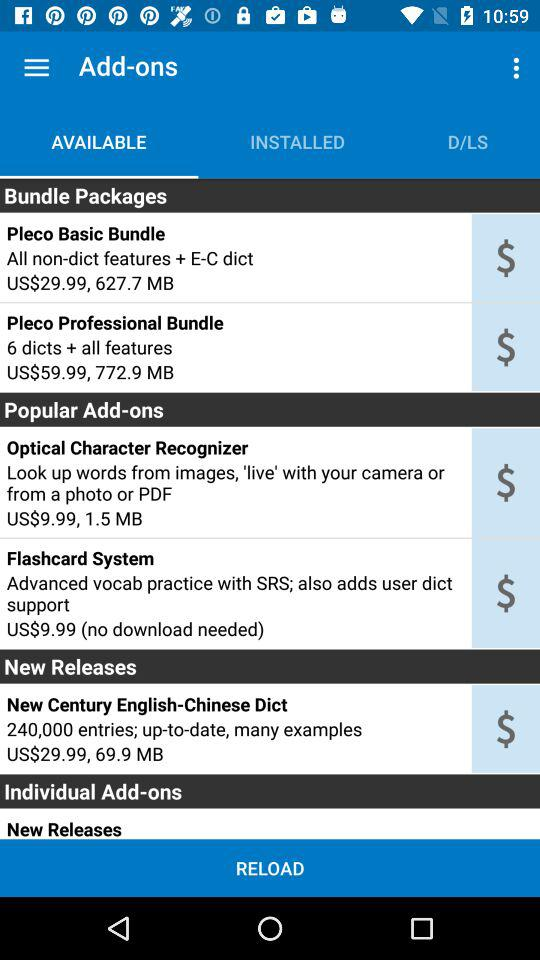What is the price of the "Pleco Basic Bundle"? The price is US $29.99. 